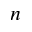<formula> <loc_0><loc_0><loc_500><loc_500>n</formula> 